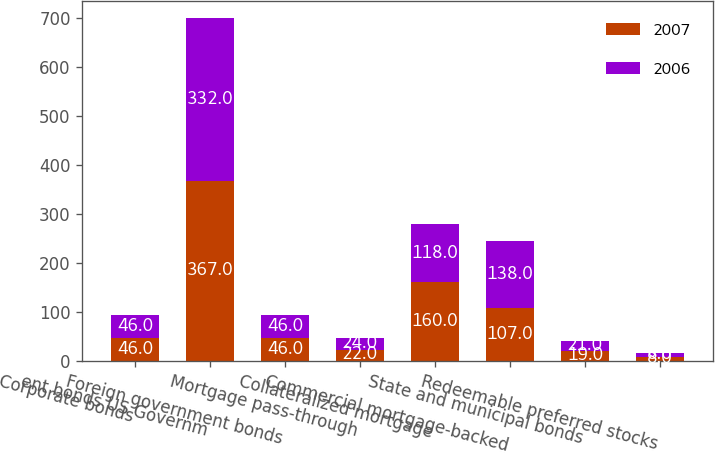<chart> <loc_0><loc_0><loc_500><loc_500><stacked_bar_chart><ecel><fcel>Corporate bonds<fcel>ent bonds US Governm<fcel>Foreign government bonds<fcel>Mortgage pass-through<fcel>Collateralized mortgage<fcel>Commercial mortgage-backed<fcel>State and municipal bonds<fcel>Redeemable preferred stocks<nl><fcel>2007<fcel>46<fcel>367<fcel>46<fcel>22<fcel>160<fcel>107<fcel>19<fcel>8<nl><fcel>2006<fcel>46<fcel>332<fcel>46<fcel>24<fcel>118<fcel>138<fcel>21<fcel>8<nl></chart> 